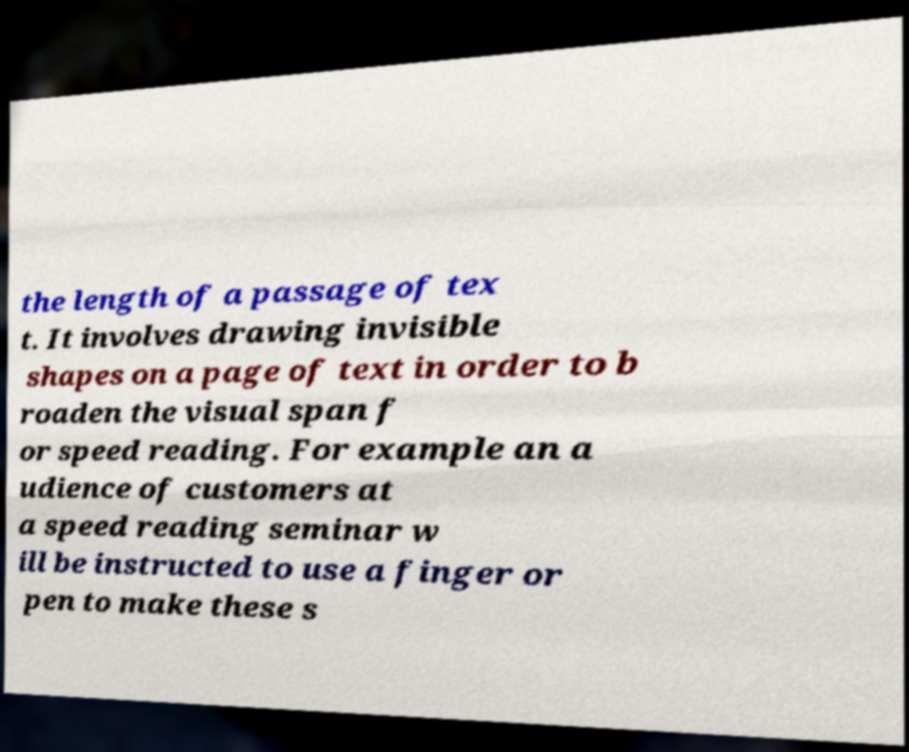Please read and relay the text visible in this image. What does it say? the length of a passage of tex t. It involves drawing invisible shapes on a page of text in order to b roaden the visual span f or speed reading. For example an a udience of customers at a speed reading seminar w ill be instructed to use a finger or pen to make these s 